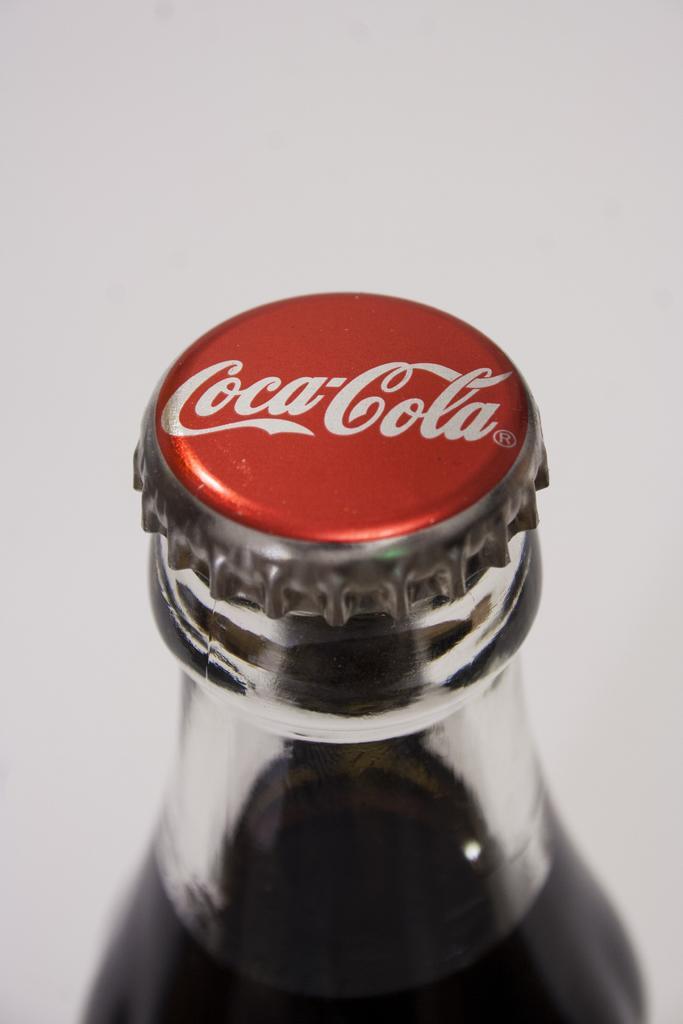Describe this image in one or two sentences. Here we can see a coca cola bottle 